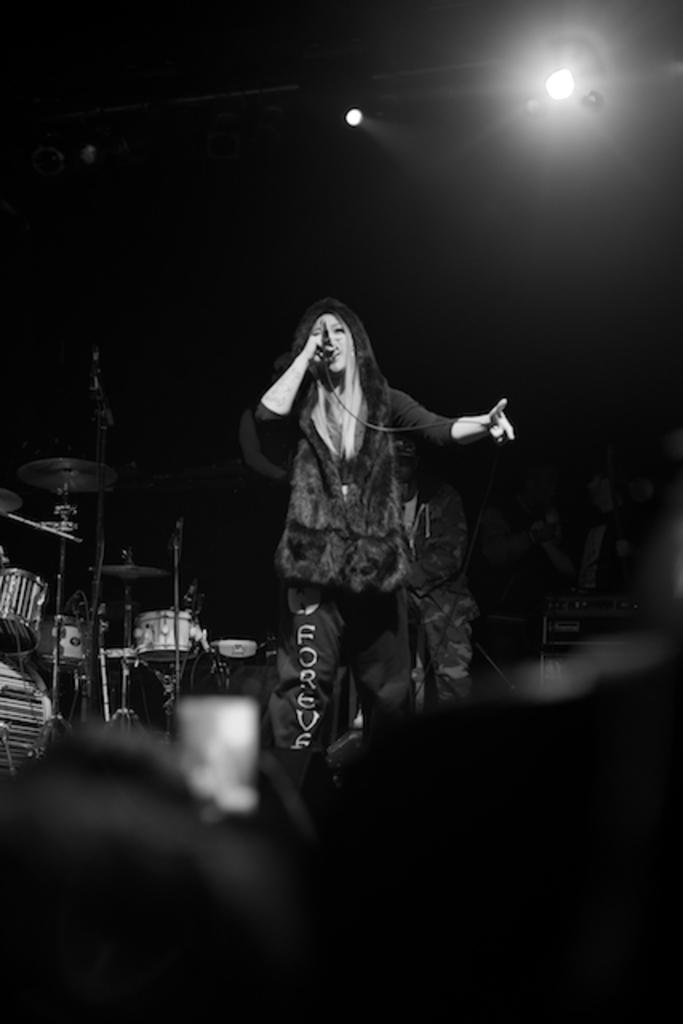Who is the main subject in the image? There is a woman in the image. What is the woman doing in the image? The woman is standing and singing on a mic. What other objects can be seen in the image? There are drums and lights visible in the image. Are there any other people in the image besides the woman? Yes, there are people in the image. How can you describe the background of the image? The background of the image is dark. What type of twig is being used as a prop in the image? There is no twig present in the image. What room is the woman performing in? The image does not provide information about the specific room where the woman is performing. 